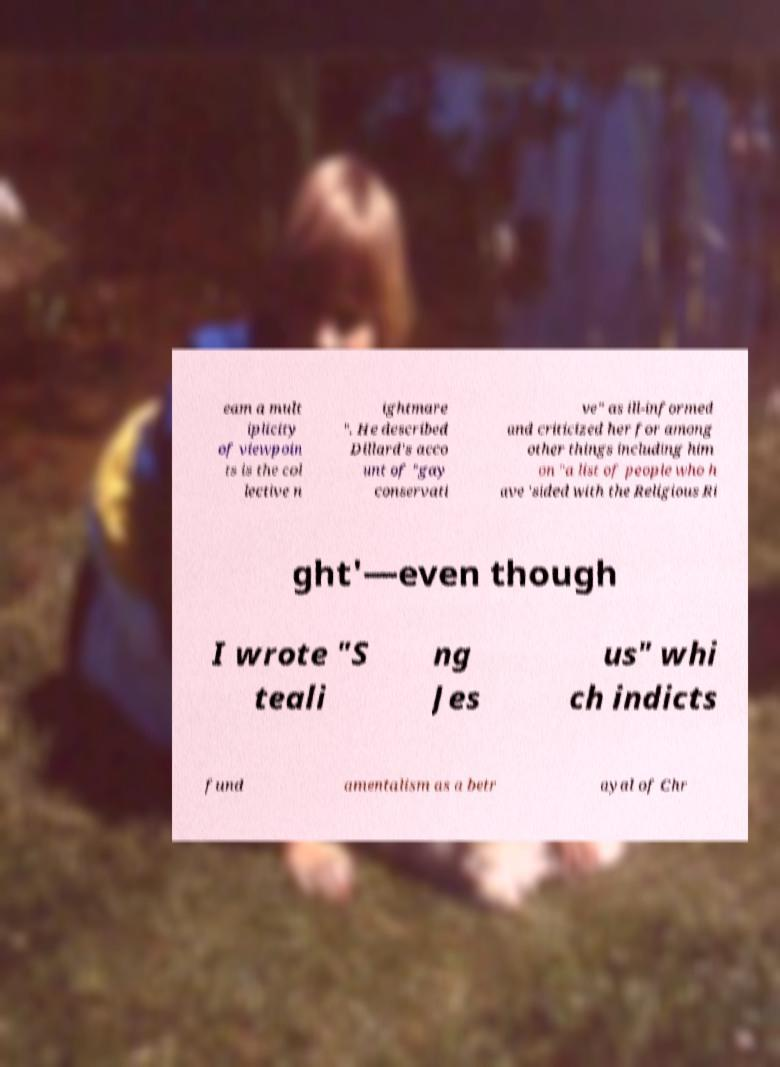Could you assist in decoding the text presented in this image and type it out clearly? eam a mult iplicity of viewpoin ts is the col lective n ightmare ". He described Dillard's acco unt of "gay conservati ve" as ill-informed and criticized her for among other things including him on "a list of people who h ave 'sided with the Religious Ri ght'—even though I wrote "S teali ng Jes us" whi ch indicts fund amentalism as a betr ayal of Chr 